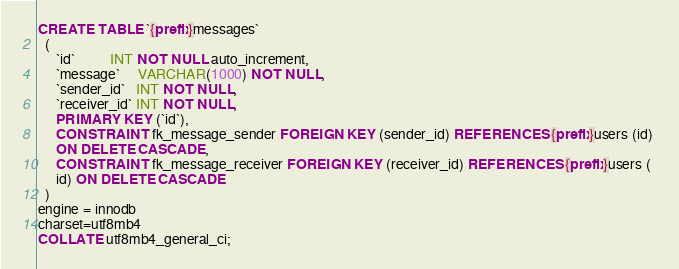<code> <loc_0><loc_0><loc_500><loc_500><_SQL_>CREATE TABLE `{prefix}messages` 
  ( 
     `id`          INT NOT NULL auto_increment, 
     `message`     VARCHAR(1000) NOT NULL, 
     `sender_id`   INT NOT NULL, 
     `receiver_id` INT NOT NULL, 
     PRIMARY KEY (`id`), 
     CONSTRAINT fk_message_sender FOREIGN KEY (sender_id) REFERENCES {prefix}users (id) 
     ON DELETE CASCADE, 
     CONSTRAINT fk_message_receiver FOREIGN KEY (receiver_id) REFERENCES {prefix}users ( 
     id) ON DELETE CASCADE 
  ) 
engine = innodb 
charset=utf8mb4 
COLLATE utf8mb4_general_ci; </code> 